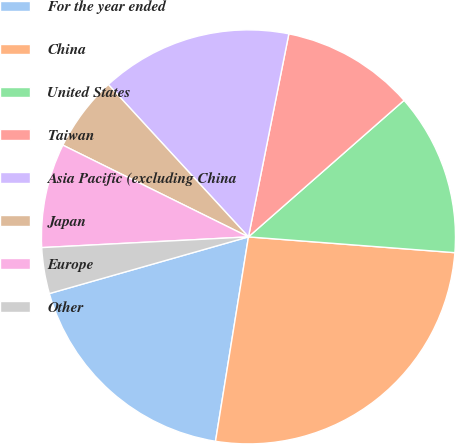<chart> <loc_0><loc_0><loc_500><loc_500><pie_chart><fcel>For the year ended<fcel>China<fcel>United States<fcel>Taiwan<fcel>Asia Pacific (excluding China<fcel>Japan<fcel>Europe<fcel>Other<nl><fcel>18.04%<fcel>26.33%<fcel>12.68%<fcel>10.41%<fcel>14.96%<fcel>5.86%<fcel>8.13%<fcel>3.59%<nl></chart> 